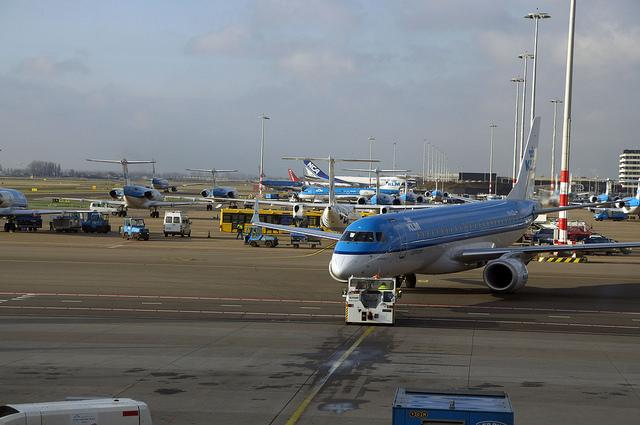What is the circular object under the wing? engine 